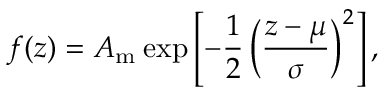Convert formula to latex. <formula><loc_0><loc_0><loc_500><loc_500>f ( z ) = A _ { m } \, e x p \left [ - \frac { 1 } { 2 } \left ( \frac { z - \mu } { \sigma } \right ) ^ { 2 } \right ] ,</formula> 